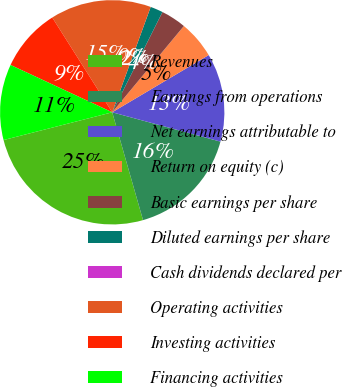<chart> <loc_0><loc_0><loc_500><loc_500><pie_chart><fcel>Revenues<fcel>Earnings from operations<fcel>Net earnings attributable to<fcel>Return on equity (c)<fcel>Basic earnings per share<fcel>Diluted earnings per share<fcel>Cash dividends declared per<fcel>Operating activities<fcel>Investing activities<fcel>Financing activities<nl><fcel>25.45%<fcel>16.36%<fcel>12.73%<fcel>5.45%<fcel>3.64%<fcel>1.82%<fcel>0.0%<fcel>14.55%<fcel>9.09%<fcel>10.91%<nl></chart> 